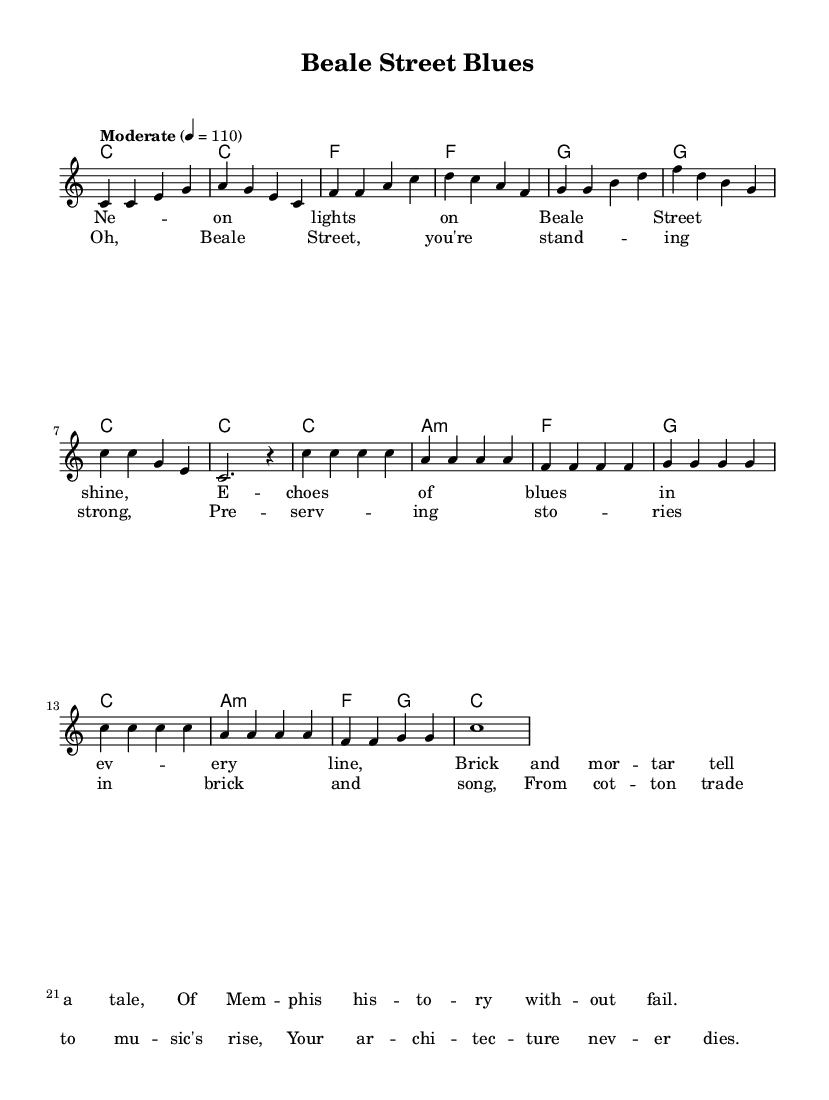What is the key signature of this music? The key signature is C major, indicated by the absence of any sharps or flats in the music.
Answer: C major What is the time signature of this piece? The time signature is 4/4, which means there are four beats in each measure, and a quarter note receives one beat. This is shown at the beginning of the score.
Answer: 4/4 What is the tempo marking for this piece? The tempo marking is "Moderate," followed by the metronome marking of 110 beats per minute, which is specified at the beginning of the score.
Answer: Moderate 4 = 110 How many measures are there in the chorus section? Counting the measures in the chorus section, there are a total of 8 measures, which can be seen in the written music.
Answer: 8 What is the predominant chord in the verse? The predominant chord in the verse is C major, which is the first chord played and continues to appear throughout the verse section.
Answer: C What lyrical theme is present in this song? The lyrical theme focuses on celebrating Beale Street and its architectural significance, highlighting its historical importance and cultural contributions within Memphis.
Answer: Celebrating Beale Street How is the structure of a typical pop song reflected in this piece? The structure reflects a typical pop song by including verses and a chorus, where the verses present the storyline and the chorus emphasizes the main message, showcasing a repetition that is characteristic of pop music.
Answer: Verse and chorus 